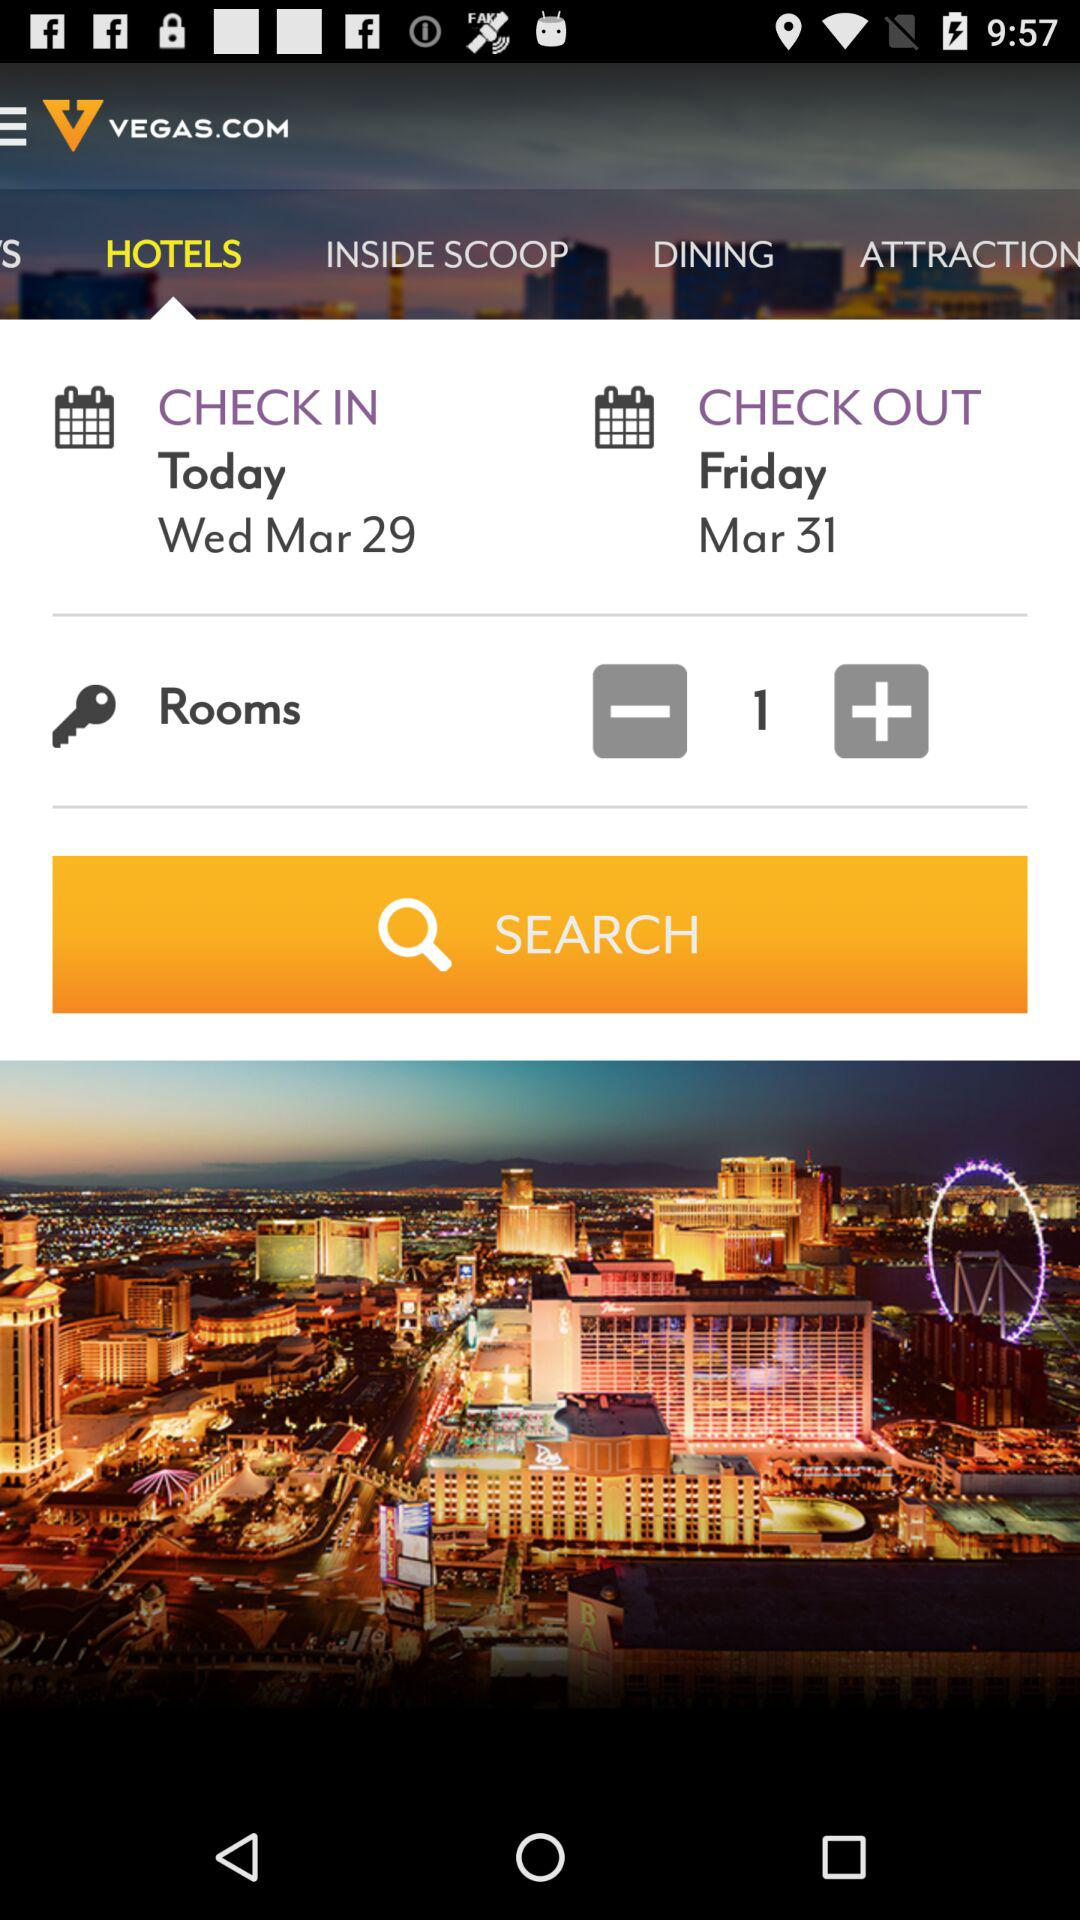How many rooms are being booked?
Answer the question using a single word or phrase. 1 